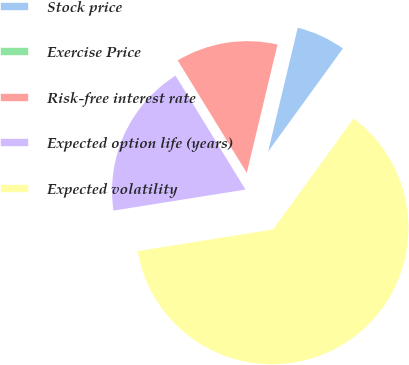<chart> <loc_0><loc_0><loc_500><loc_500><pie_chart><fcel>Stock price<fcel>Exercise Price<fcel>Risk-free interest rate<fcel>Expected option life (years)<fcel>Expected volatility<nl><fcel>6.25%<fcel>0.0%<fcel>12.5%<fcel>18.75%<fcel>62.49%<nl></chart> 